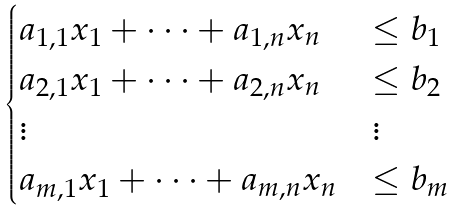<formula> <loc_0><loc_0><loc_500><loc_500>\begin{cases} a _ { 1 , 1 } x _ { 1 } + \cdots + a _ { 1 , n } x _ { n } & \leq b _ { 1 } \\ a _ { 2 , 1 } x _ { 1 } + \cdots + a _ { 2 , n } x _ { n } & \leq b _ { 2 } \\ \vdots & \vdots \\ a _ { m , 1 } x _ { 1 } + \cdots + a _ { m , n } x _ { n } & \leq b _ { m } \end{cases}</formula> 